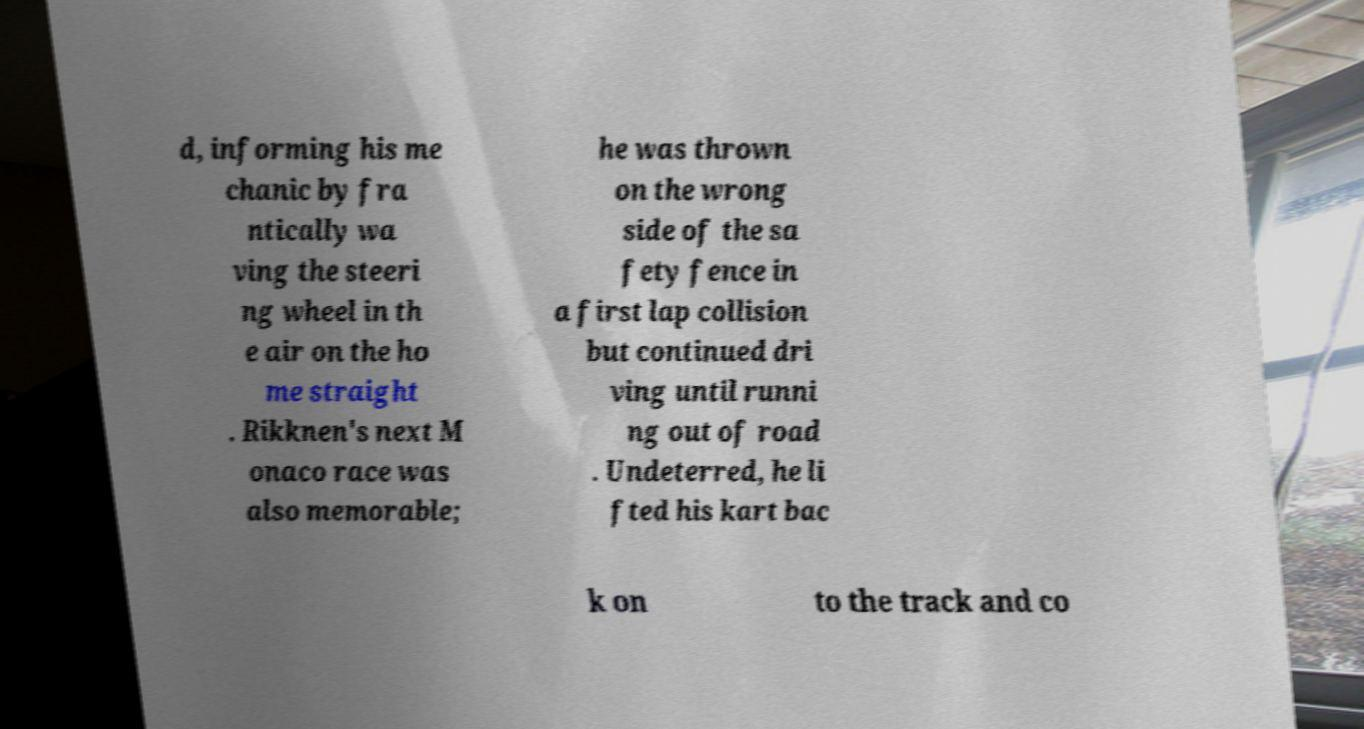There's text embedded in this image that I need extracted. Can you transcribe it verbatim? d, informing his me chanic by fra ntically wa ving the steeri ng wheel in th e air on the ho me straight . Rikknen's next M onaco race was also memorable; he was thrown on the wrong side of the sa fety fence in a first lap collision but continued dri ving until runni ng out of road . Undeterred, he li fted his kart bac k on to the track and co 